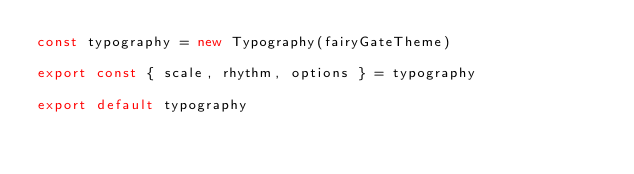<code> <loc_0><loc_0><loc_500><loc_500><_TypeScript_>const typography = new Typography(fairyGateTheme)

export const { scale, rhythm, options } = typography

export default typography
</code> 